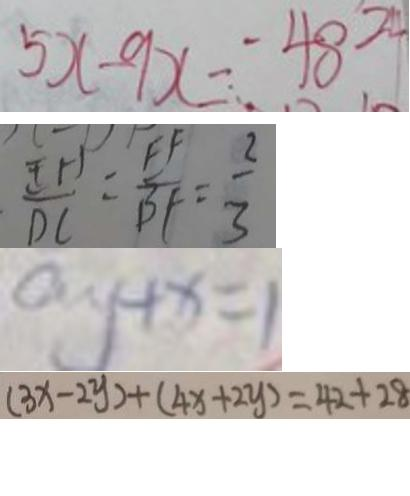<formula> <loc_0><loc_0><loc_500><loc_500>5 x - 9 x = - 4 8 - 2 4 
 \frac { E H } { D C } = \frac { E F } { B F } = \frac { 2 } { 3 } 
 a y + x = 1 
 ( 3 x - 2 y ) + ( 4 x + 2 y ) = 4 2 + 2 8</formula> 